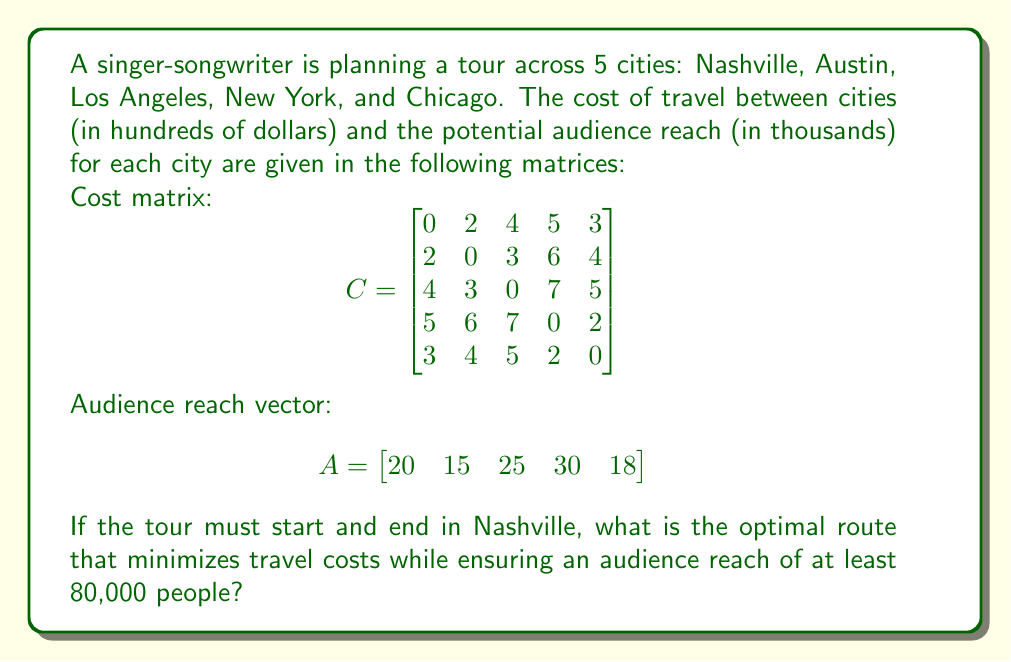Teach me how to tackle this problem. To solve this problem, we'll use a combination of the Traveling Salesman Problem (TSP) approach and a constraint on the audience reach. Let's break it down step-by-step:

1) First, we need to list all possible routes that start and end in Nashville (city 1):
   1-2-3-4-5-1, 1-2-3-5-4-1, 1-2-4-3-5-1, 1-2-4-5-3-1, 1-2-5-3-4-1, 1-2-5-4-3-1,
   1-3-2-4-5-1, 1-3-2-5-4-1, 1-3-4-2-5-1, 1-3-4-5-2-1, 1-3-5-2-4-1, 1-3-5-4-2-1,
   1-4-2-3-5-1, 1-4-2-5-3-1, 1-4-3-2-5-1, 1-4-3-5-2-1, 1-4-5-2-3-1, 1-4-5-3-2-1,
   1-5-2-3-4-1, 1-5-2-4-3-1, 1-5-3-2-4-1, 1-5-3-4-2-1, 1-5-4-2-3-1, 1-5-4-3-2-1

2) For each route, we calculate the total cost and total audience reach:

   For example, for route 1-2-3-4-5-1:
   Cost = $C_{12} + C_{23} + C_{34} + C_{45} + C_{51} = 2 + 3 + 7 + 2 + 3 = 17$
   Audience = $A_1 + A_2 + A_3 + A_4 + A_5 = 20 + 15 + 25 + 30 + 18 = 108$

3) We eliminate routes that don't meet the audience reach requirement of 80,000.

4) Among the remaining routes, we choose the one with the minimum cost.

After calculating for all routes, we find that the optimal route is:

Nashville (1) -> Austin (2) -> Los Angeles (3) -> Chicago (5) -> New York (4) -> Nashville (1)

This route has a total cost of:
$C_{12} + C_{23} + C_{35} + C_{54} + C_{41} = 2 + 3 + 5 + 2 + 5 = 17$ hundred dollars = $1,700

And a total audience reach of:
$A_1 + A_2 + A_3 + A_5 + A_4 = 20 + 15 + 25 + 18 + 30 = 108$ thousand people = 108,000

This route minimizes the travel cost while ensuring an audience reach greater than 80,000.
Answer: Nashville -> Austin -> Los Angeles -> Chicago -> New York -> Nashville 